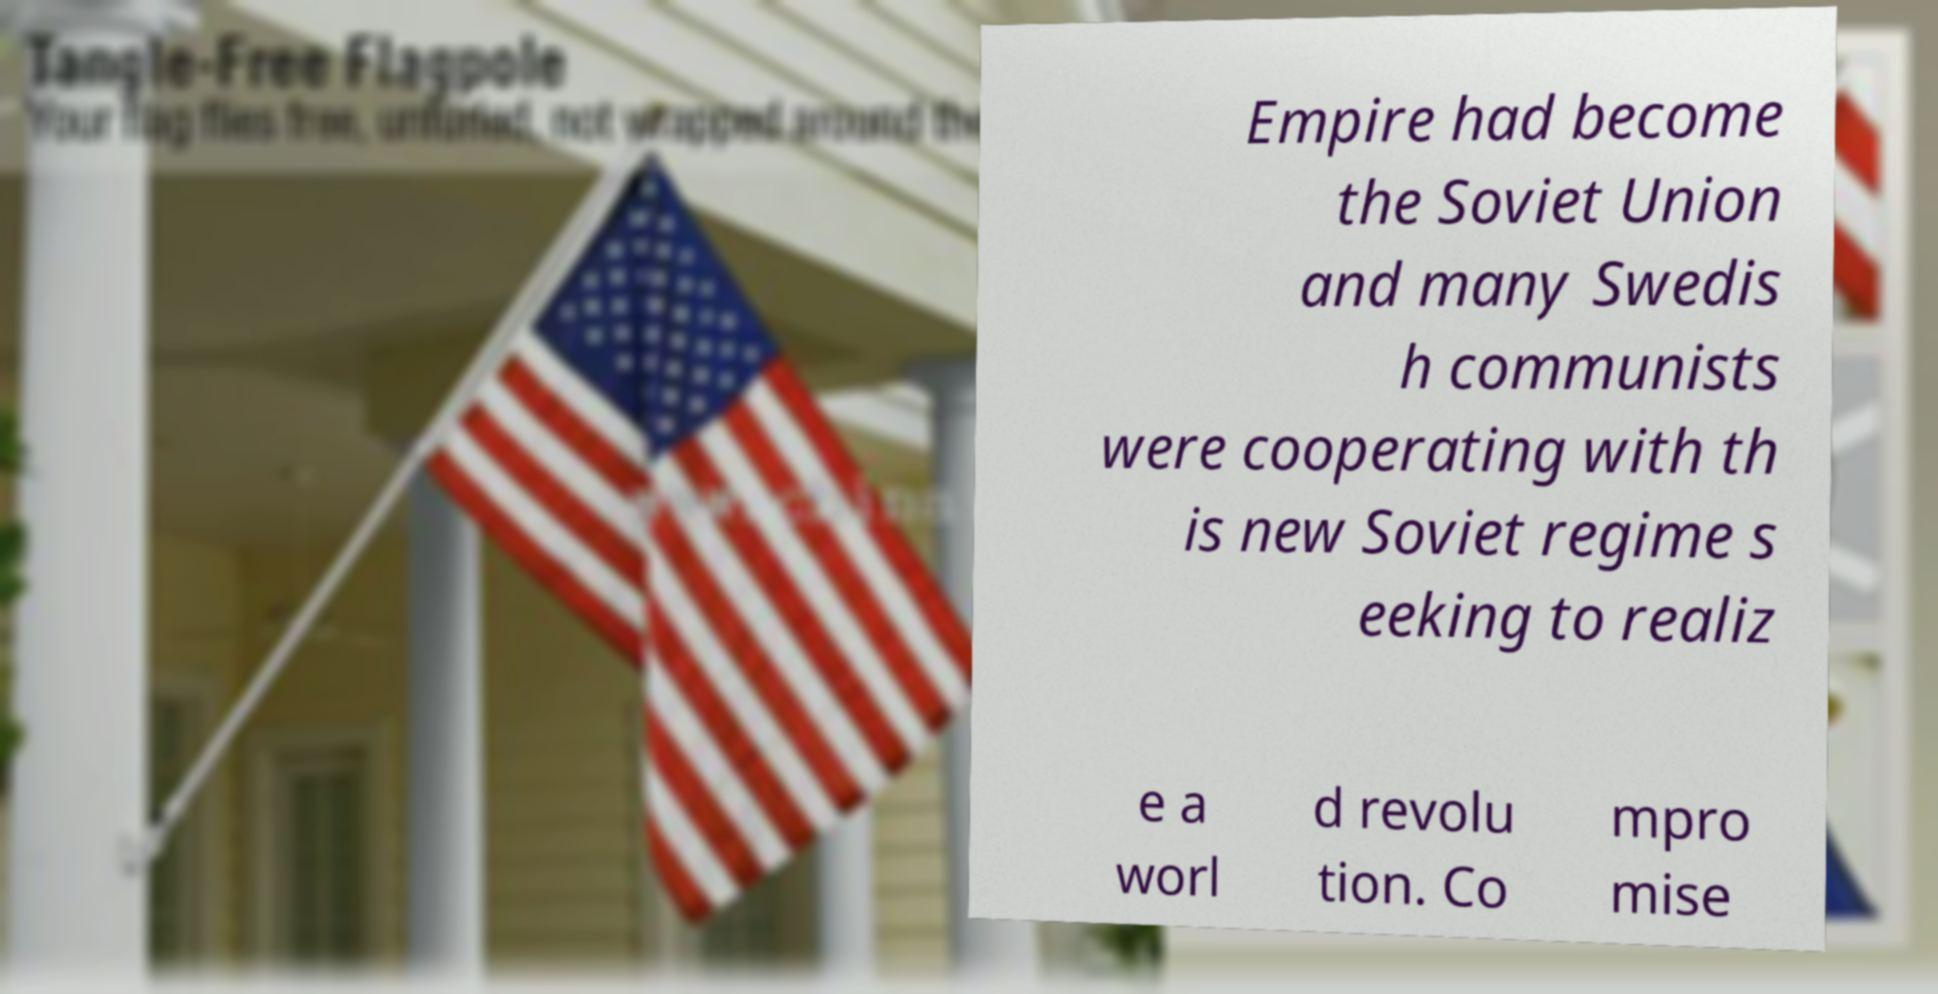Could you assist in decoding the text presented in this image and type it out clearly? Empire had become the Soviet Union and many Swedis h communists were cooperating with th is new Soviet regime s eeking to realiz e a worl d revolu tion. Co mpro mise 